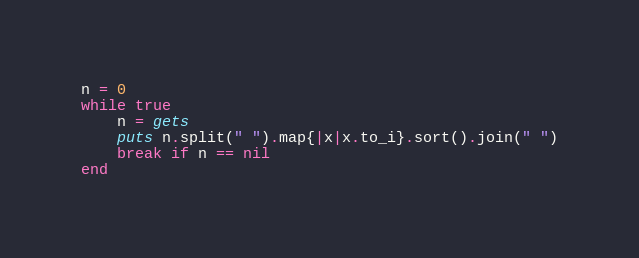<code> <loc_0><loc_0><loc_500><loc_500><_Ruby_>n = 0
while true
	n = gets
	puts n.split(" ").map{|x|x.to_i}.sort().join(" ")
	break if n == nil
end</code> 